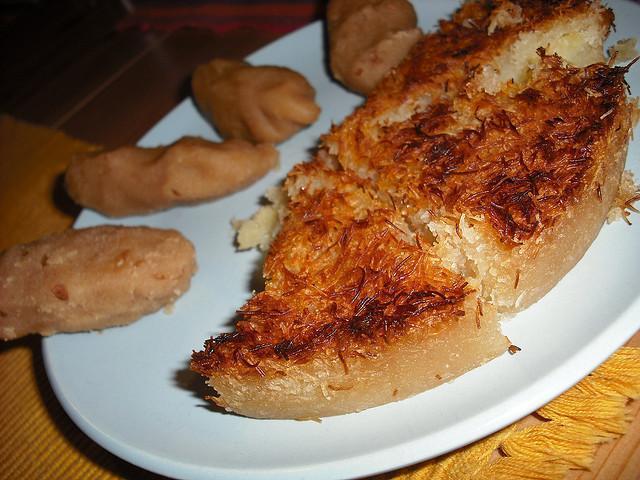How many pizzas are there?
Give a very brief answer. 2. 